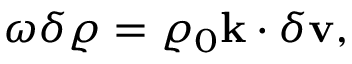<formula> <loc_0><loc_0><loc_500><loc_500>\begin{array} { r } { \omega \delta \varrho = \varrho _ { 0 } k \cdot \delta v , } \end{array}</formula> 